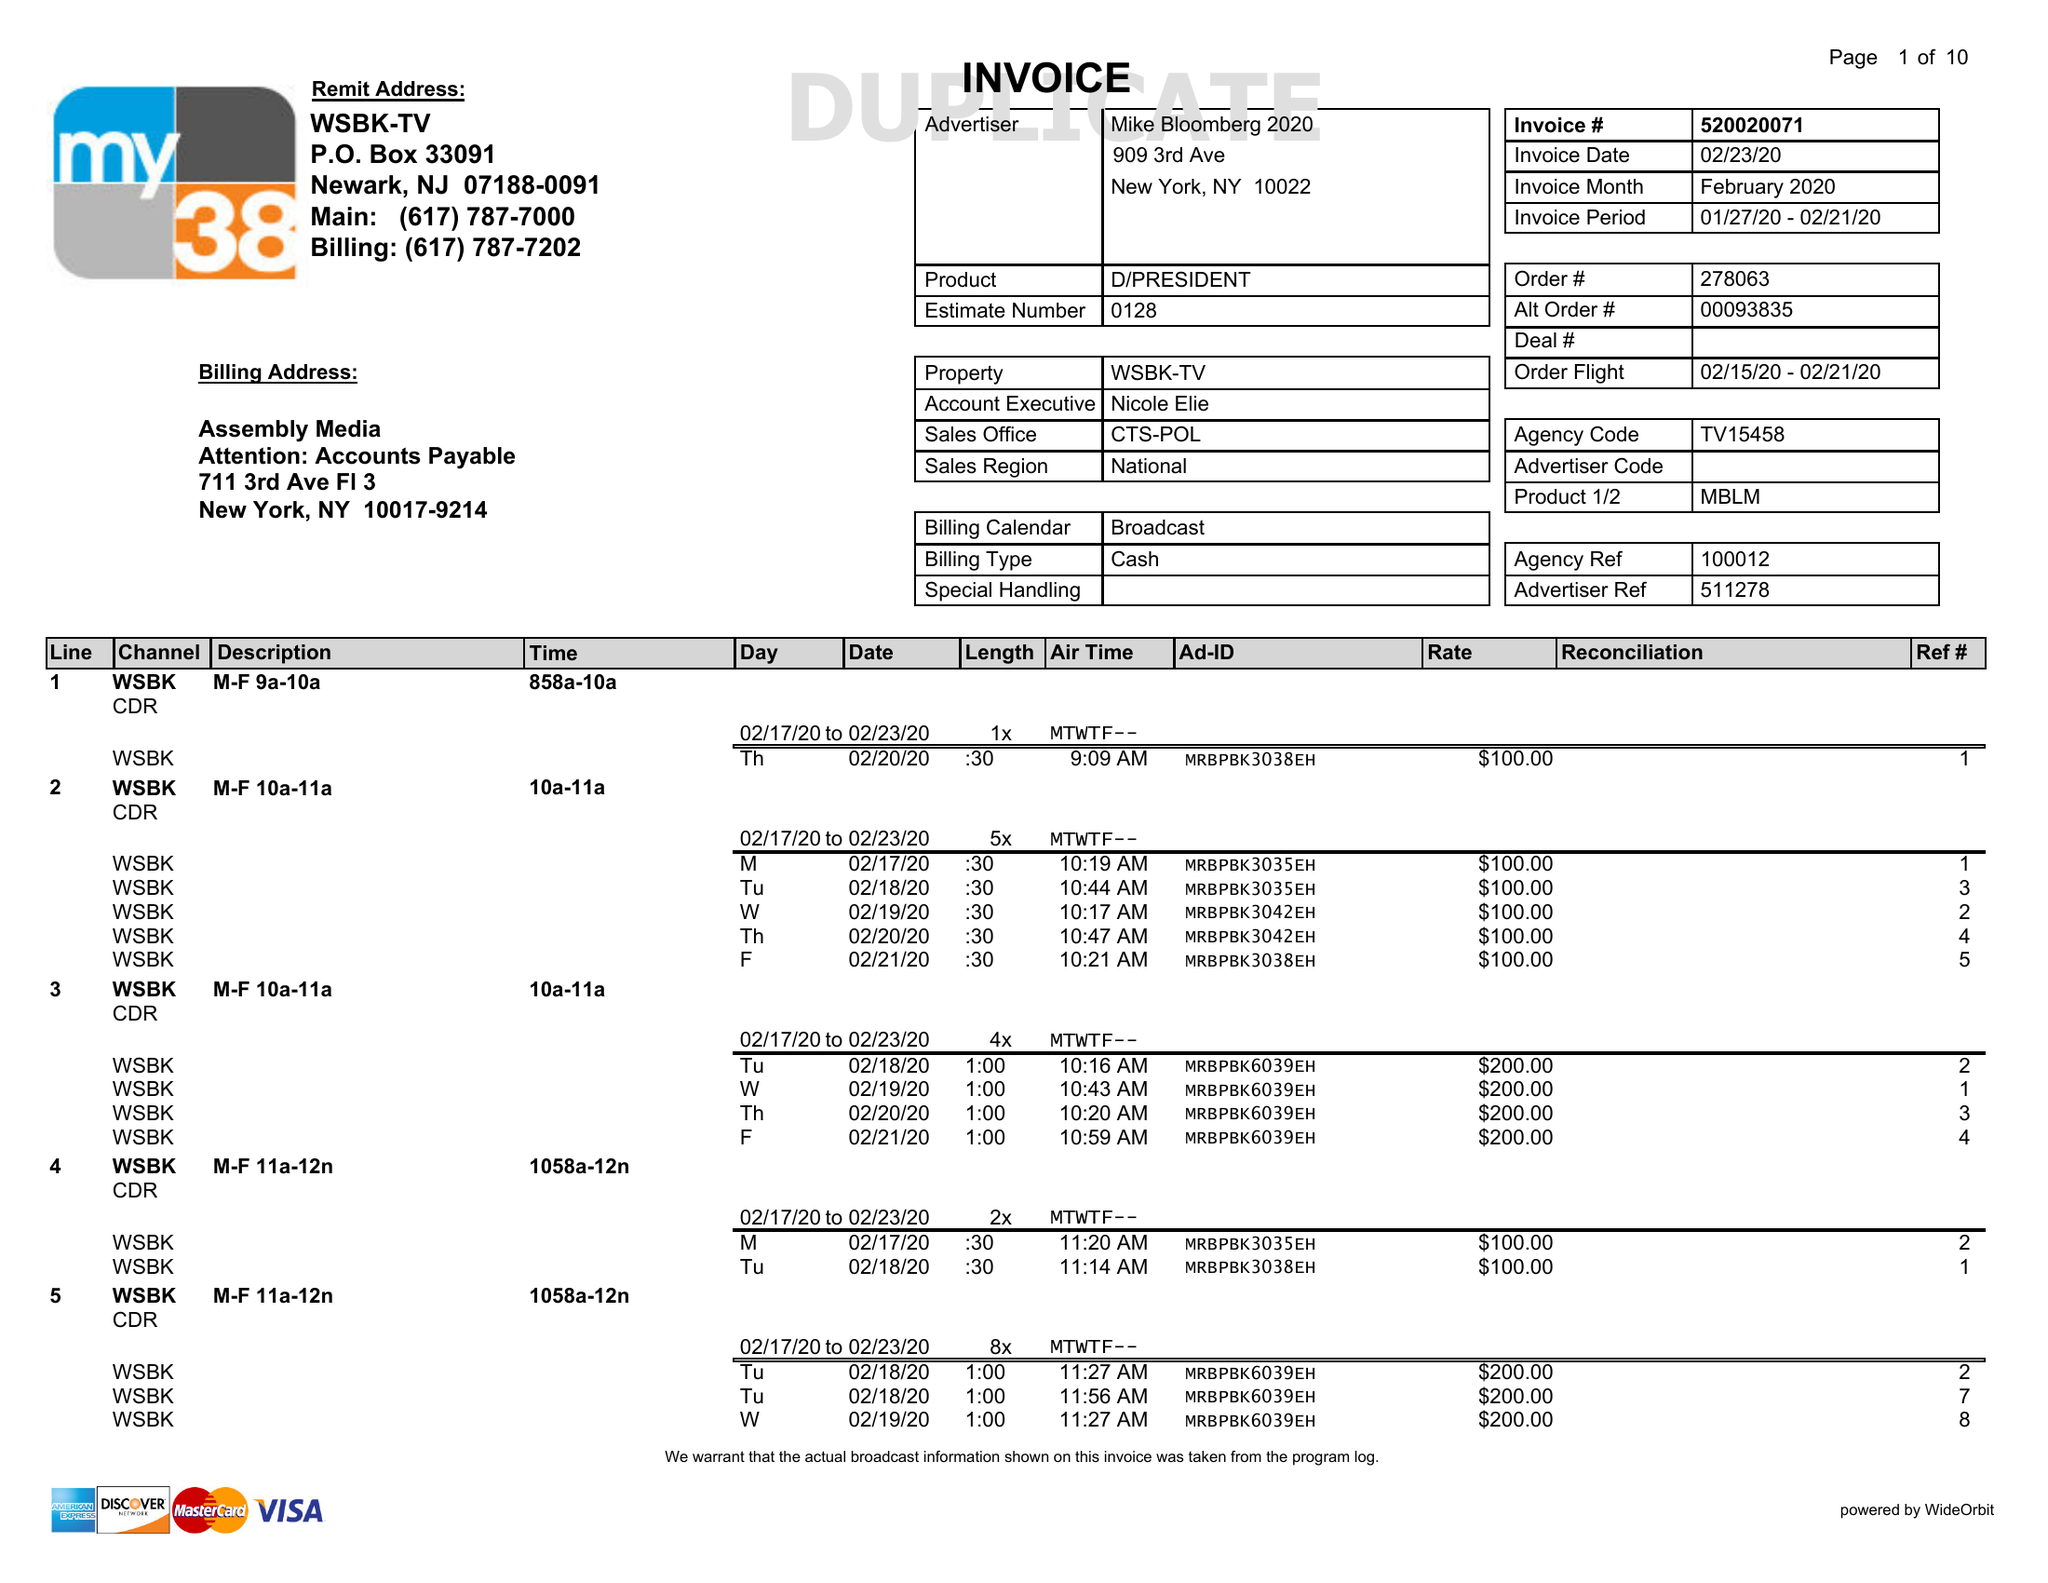What is the value for the gross_amount?
Answer the question using a single word or phrase. 35975.00 